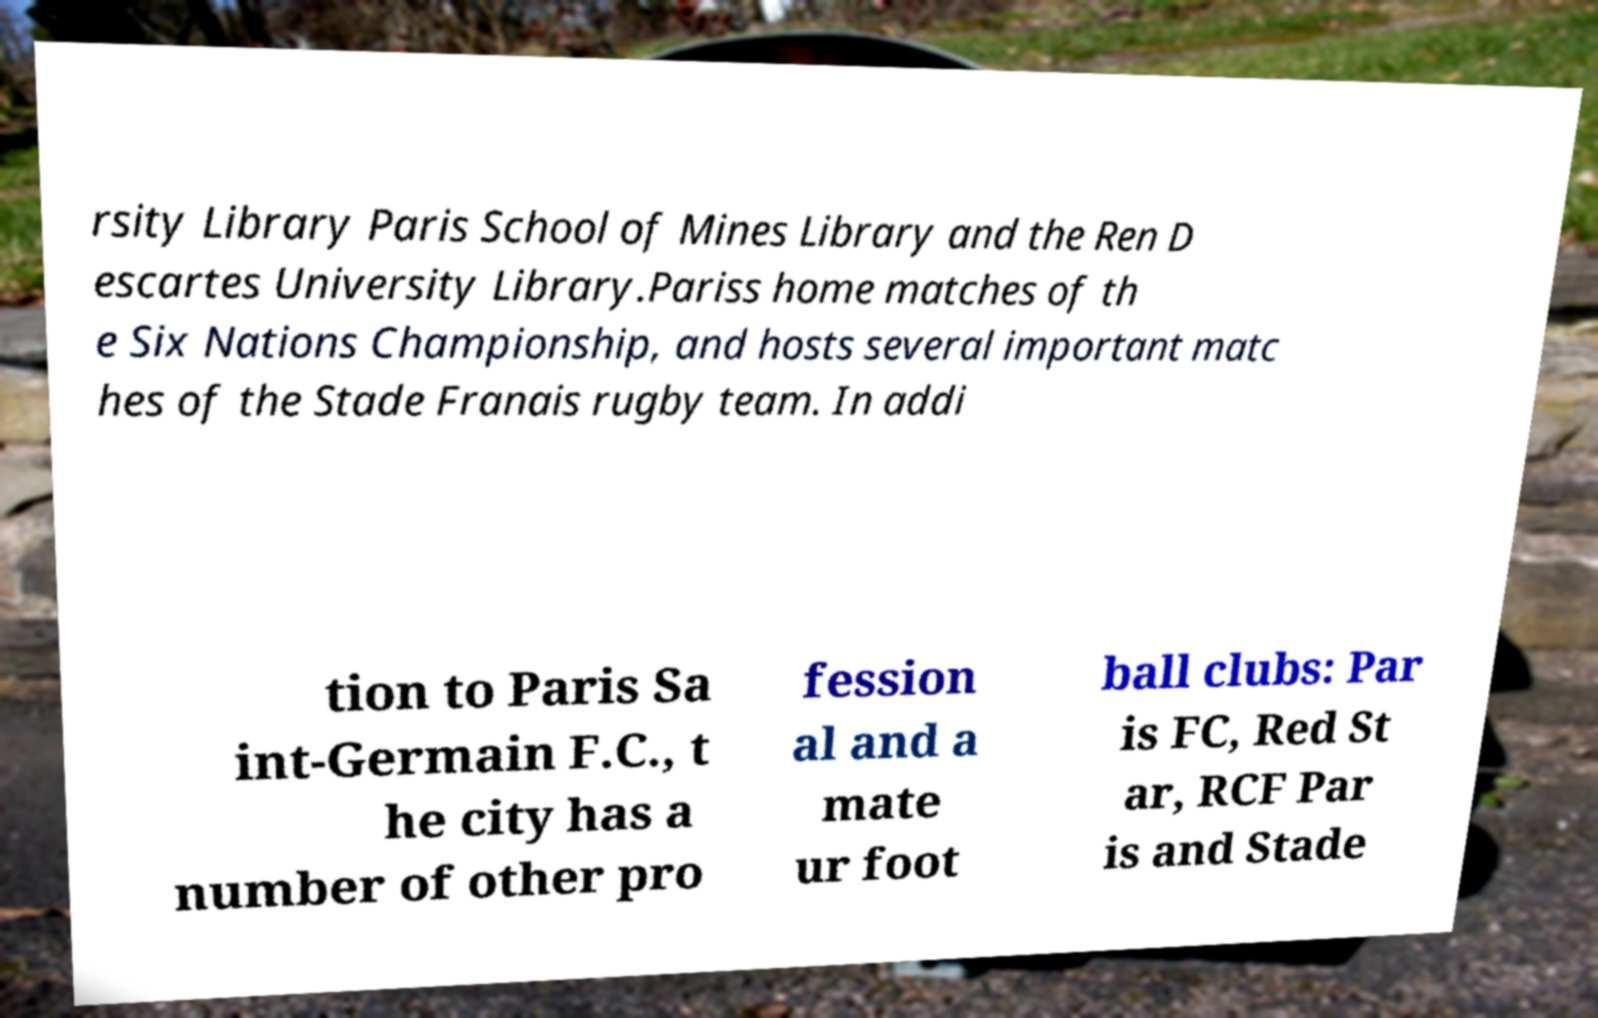Can you read and provide the text displayed in the image?This photo seems to have some interesting text. Can you extract and type it out for me? rsity Library Paris School of Mines Library and the Ren D escartes University Library.Pariss home matches of th e Six Nations Championship, and hosts several important matc hes of the Stade Franais rugby team. In addi tion to Paris Sa int-Germain F.C., t he city has a number of other pro fession al and a mate ur foot ball clubs: Par is FC, Red St ar, RCF Par is and Stade 